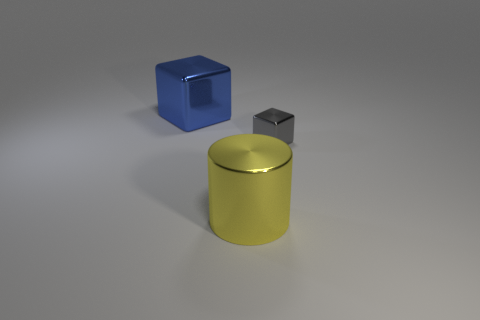Is there anything else that is the same size as the gray metal object?
Your response must be concise. No. There is a tiny object that is made of the same material as the big blue cube; what is its shape?
Your response must be concise. Cube. Is there anything else that has the same color as the tiny metal block?
Make the answer very short. No. The yellow object that is the same material as the big cube is what size?
Keep it short and to the point. Large. There is a block that is right of the blue metallic thing; is its size the same as the yellow metal object?
Give a very brief answer. No. There is a big metallic thing in front of the large object behind the big shiny object that is to the right of the blue object; what shape is it?
Give a very brief answer. Cylinder. What number of things are big blue metallic objects or large objects that are in front of the gray shiny object?
Offer a terse response. 2. There is a shiny thing that is in front of the tiny thing; what is its size?
Your answer should be compact. Large. Is the material of the yellow object the same as the cube that is to the right of the big blue object?
Your answer should be very brief. Yes. How many yellow shiny cylinders are behind the cube in front of the large metallic thing on the left side of the large yellow cylinder?
Make the answer very short. 0. 